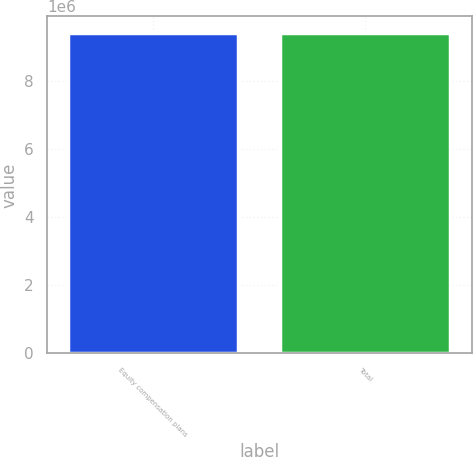Convert chart to OTSL. <chart><loc_0><loc_0><loc_500><loc_500><bar_chart><fcel>Equity compensation plans<fcel>Total<nl><fcel>9.42575e+06<fcel>9.42575e+06<nl></chart> 